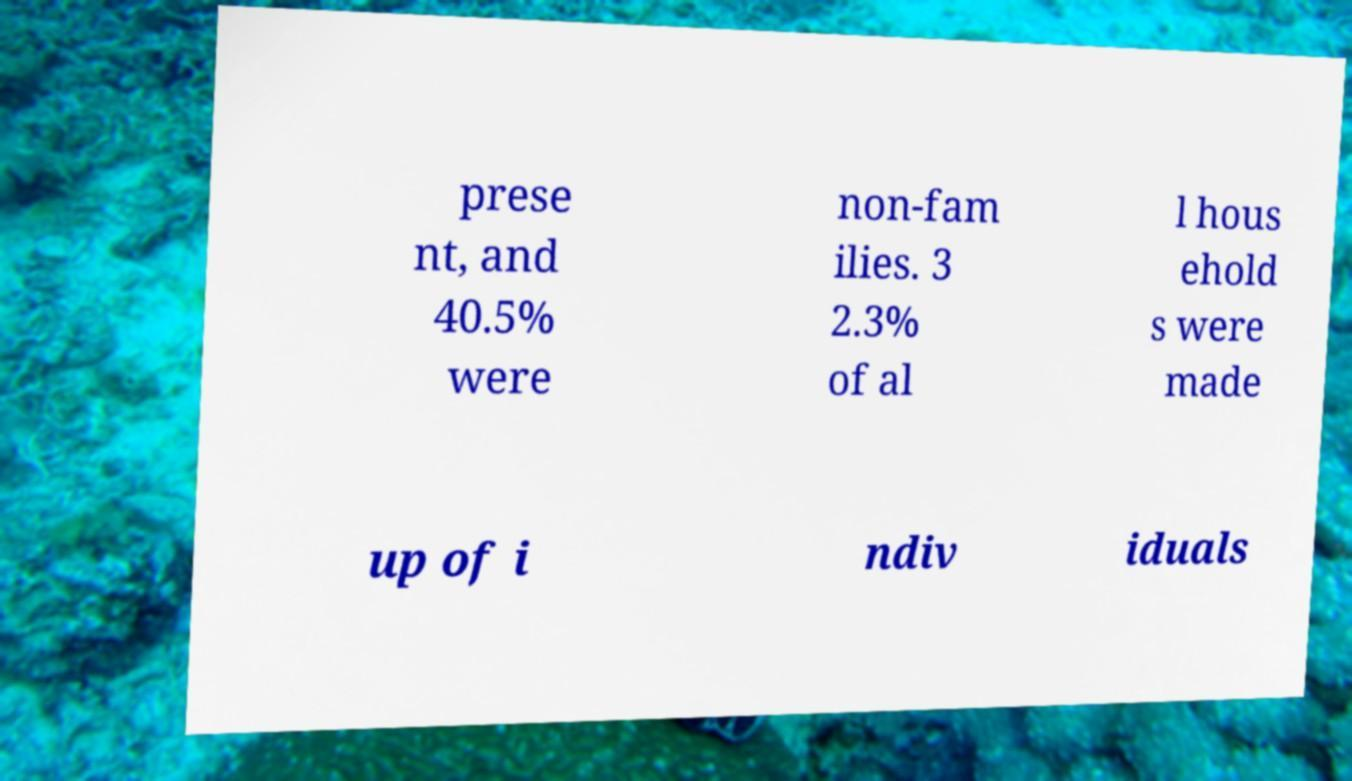What messages or text are displayed in this image? I need them in a readable, typed format. prese nt, and 40.5% were non-fam ilies. 3 2.3% of al l hous ehold s were made up of i ndiv iduals 